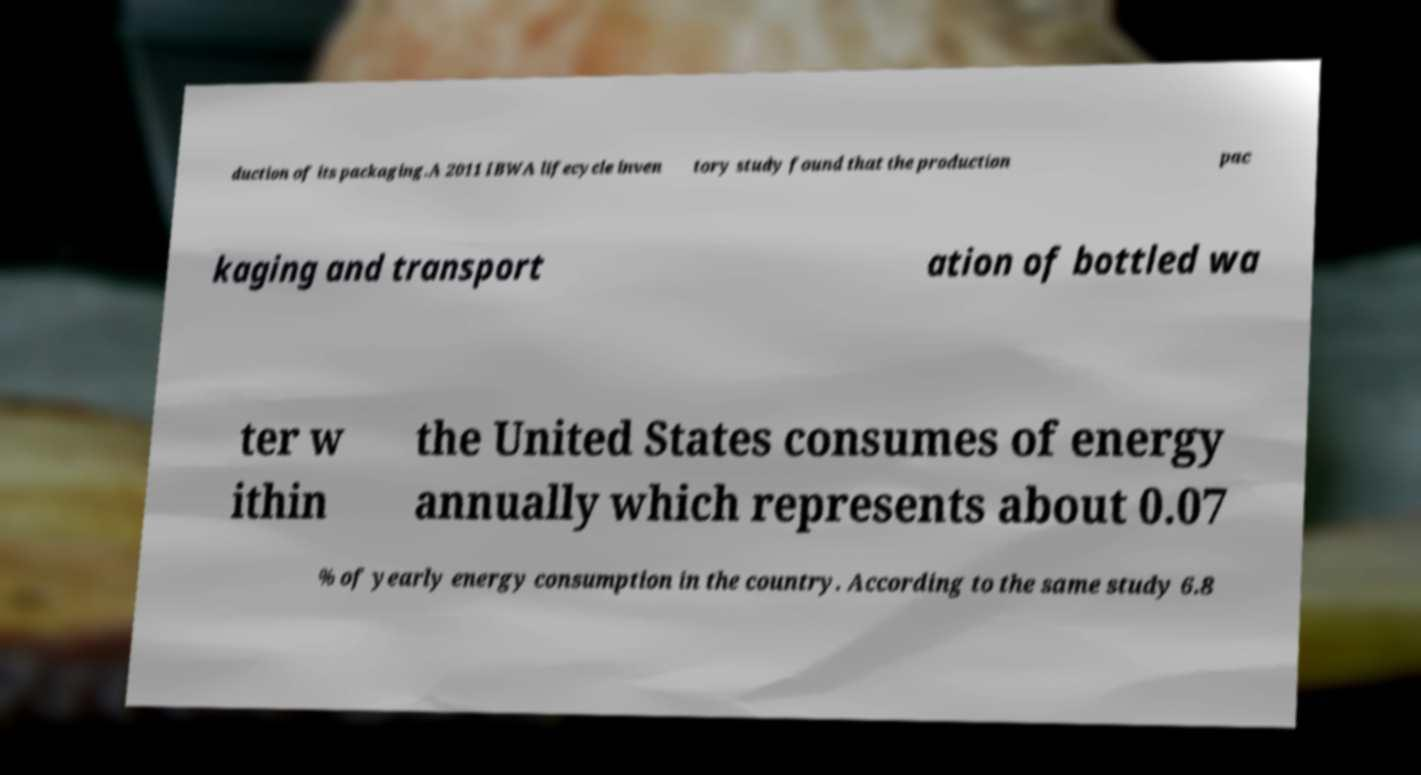Please identify and transcribe the text found in this image. duction of its packaging.A 2011 IBWA lifecycle inven tory study found that the production pac kaging and transport ation of bottled wa ter w ithin the United States consumes of energy annually which represents about 0.07 % of yearly energy consumption in the country. According to the same study 6.8 